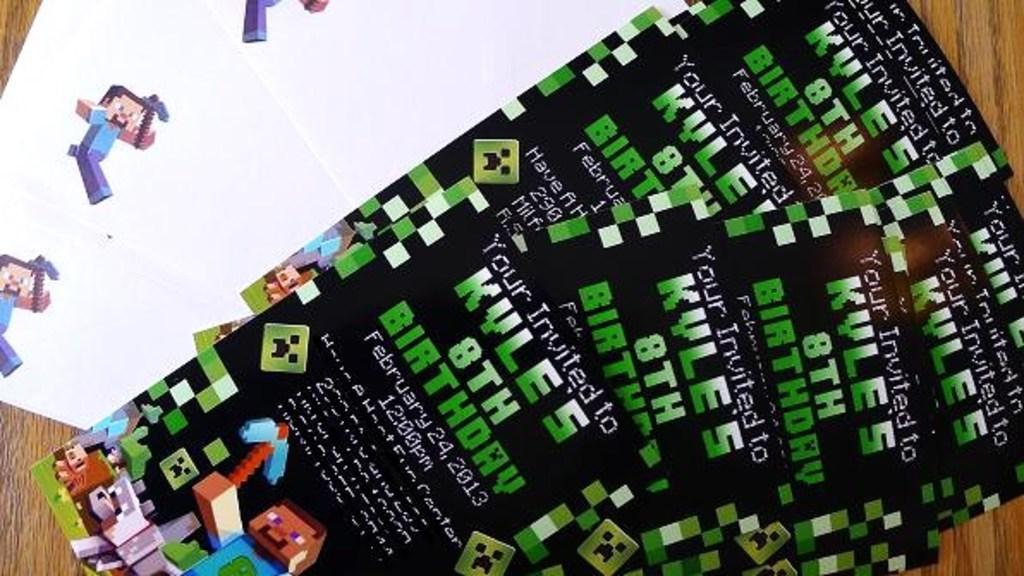Describe this image in one or two sentences. This picture shows few invitation cards and a paper on the table and we see text on the cards and a cartoon picture. 